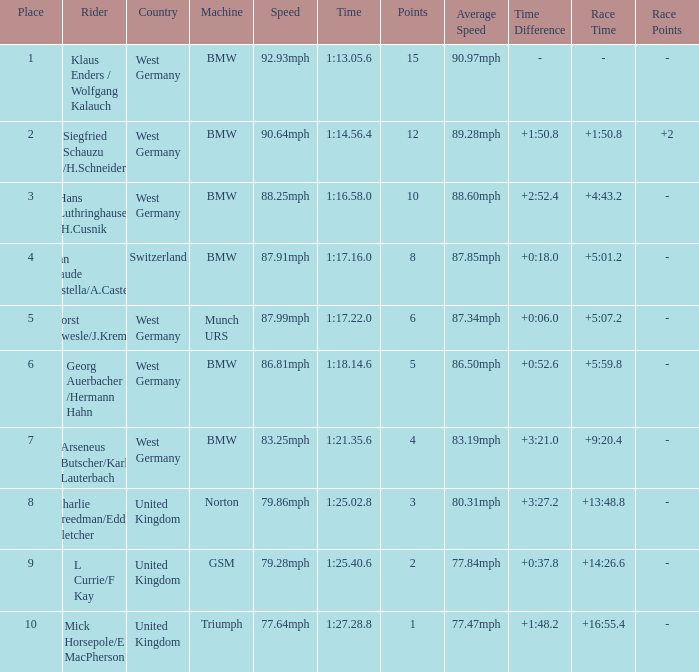Parse the table in full. {'header': ['Place', 'Rider', 'Country', 'Machine', 'Speed', 'Time', 'Points', 'Average Speed', 'Time Difference', 'Race Time', 'Race Points'], 'rows': [['1', 'Klaus Enders / Wolfgang Kalauch', 'West Germany', 'BMW', '92.93mph', '1:13.05.6', '15', '90.97mph', '-', '-', '-'], ['2', 'Siegfried Schauzu /H.Schneider', 'West Germany', 'BMW', '90.64mph', '1:14.56.4', '12', '89.28mph', '+1:50.8', '+1:50.8', '+2'], ['3', 'Hans Luthringhauser /H.Cusnik', 'West Germany', 'BMW', '88.25mph', '1:16.58.0', '10', '88.60mph', '+2:52.4', '+4:43.2', '-'], ['4', 'Jean Claude Castella/A.Castella', 'Switzerland', 'BMW', '87.91mph', '1:17.16.0', '8', '87.85mph', '+0:18.0', '+5:01.2', '-'], ['5', 'Horst Owesle/J.Kremer', 'West Germany', 'Munch URS', '87.99mph', '1:17.22.0', '6', '87.34mph', '+0:06.0', '+5:07.2', '-'], ['6', 'Georg Auerbacher /Hermann Hahn', 'West Germany', 'BMW', '86.81mph', '1:18.14.6', '5', '86.50mph', '+0:52.6', '+5:59.8', '-'], ['7', 'Arseneus Butscher/Karl Lauterbach', 'West Germany', 'BMW', '83.25mph', '1:21.35.6', '4', '83.19mph', '+3:21.0', '+9:20.4', '-'], ['8', 'Charlie Freedman/Eddie Fletcher', 'United Kingdom', 'Norton', '79.86mph', '1:25.02.8', '3', '80.31mph', '+3:27.2', '+13:48.8', '-'], ['9', 'L Currie/F Kay', 'United Kingdom', 'GSM', '79.28mph', '1:25.40.6', '2', '77.84mph', '+0:37.8', '+14:26.6', '-'], ['10', 'Mick Horsepole/E MacPherson', 'United Kingdom', 'Triumph', '77.64mph', '1:27.28.8', '1', '77.47mph', '+1:48.2', '+16:55.4', '-']]} Which places have points larger than 10? None. 